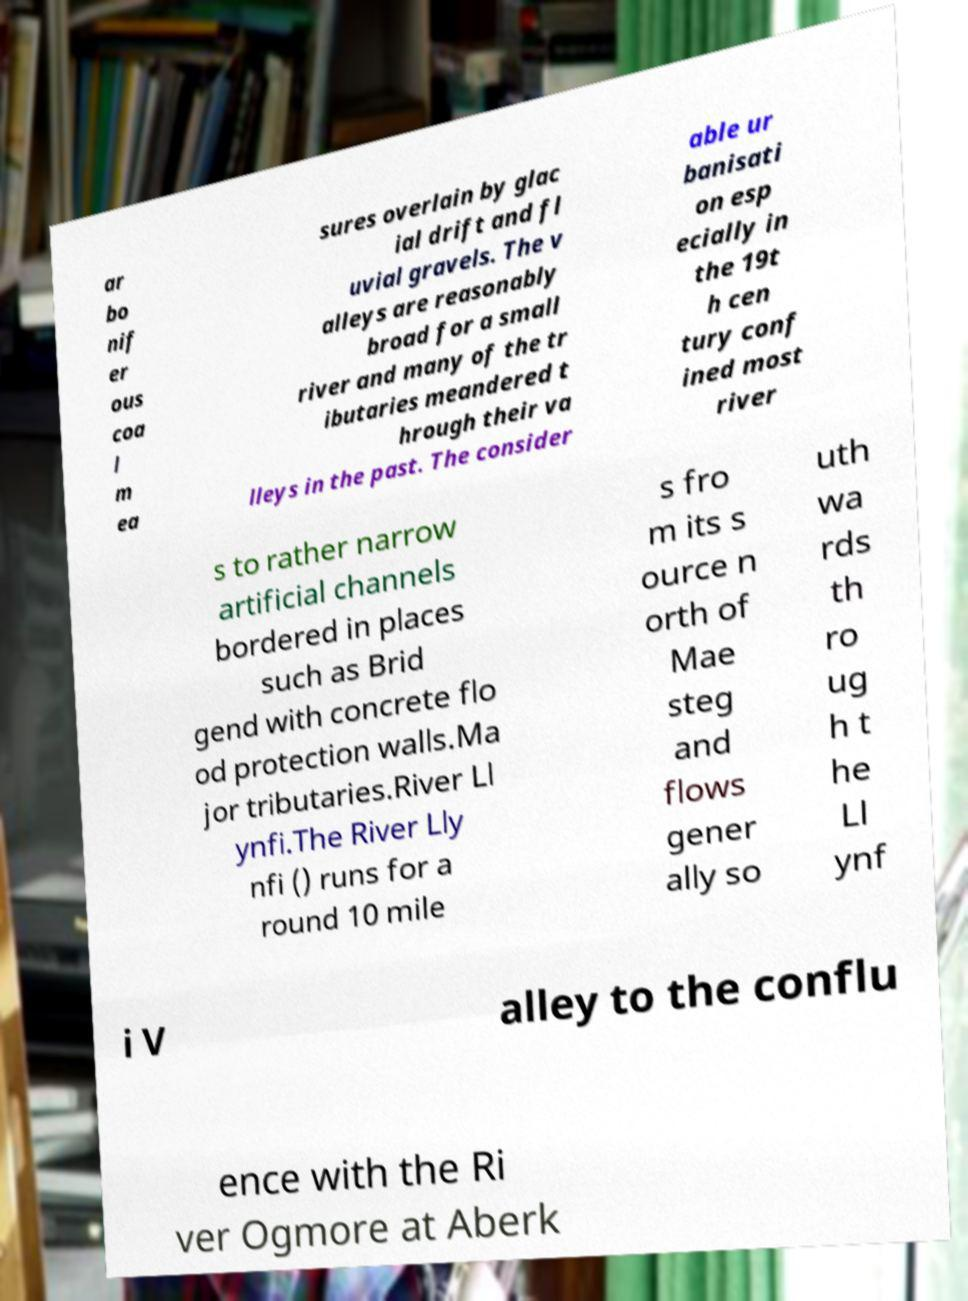Please read and relay the text visible in this image. What does it say? ar bo nif er ous coa l m ea sures overlain by glac ial drift and fl uvial gravels. The v alleys are reasonably broad for a small river and many of the tr ibutaries meandered t hrough their va lleys in the past. The consider able ur banisati on esp ecially in the 19t h cen tury conf ined most river s to rather narrow artificial channels bordered in places such as Brid gend with concrete flo od protection walls.Ma jor tributaries.River Ll ynfi.The River Lly nfi () runs for a round 10 mile s fro m its s ource n orth of Mae steg and flows gener ally so uth wa rds th ro ug h t he Ll ynf i V alley to the conflu ence with the Ri ver Ogmore at Aberk 